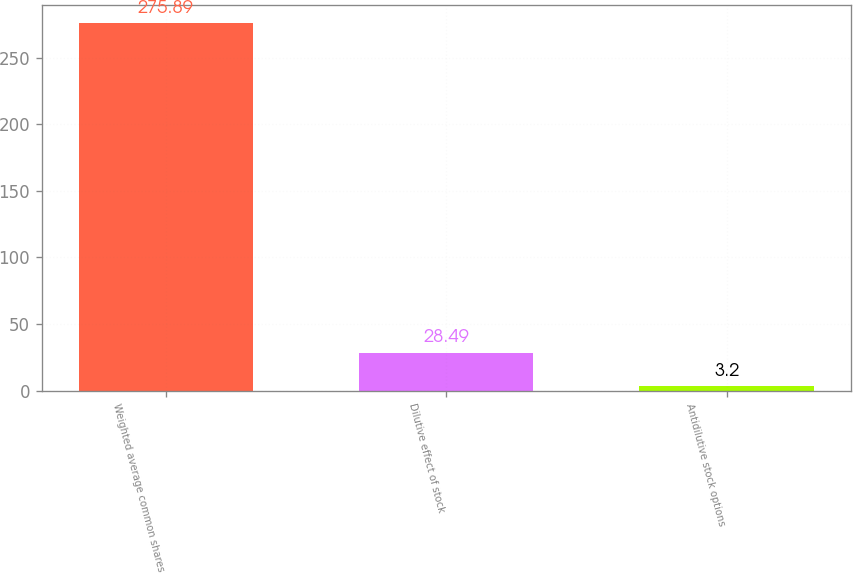Convert chart. <chart><loc_0><loc_0><loc_500><loc_500><bar_chart><fcel>Weighted average common shares<fcel>Dilutive effect of stock<fcel>Antidilutive stock options<nl><fcel>275.89<fcel>28.49<fcel>3.2<nl></chart> 